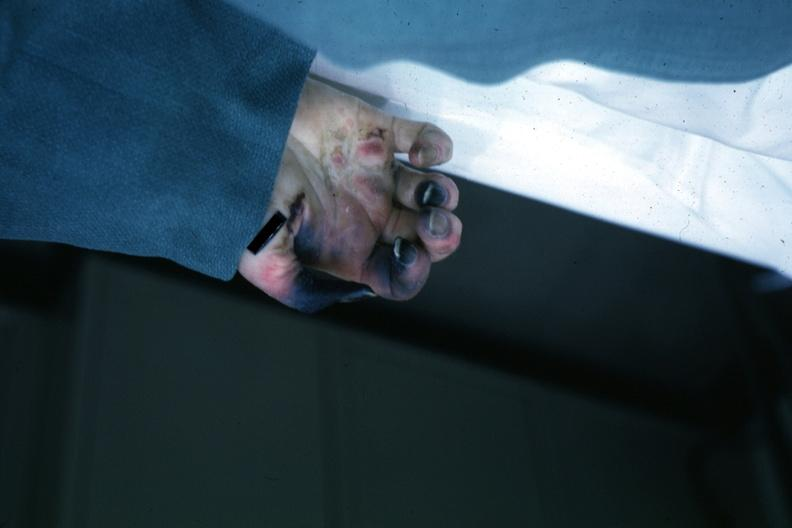what are present?
Answer the question using a single word or phrase. Extremities 